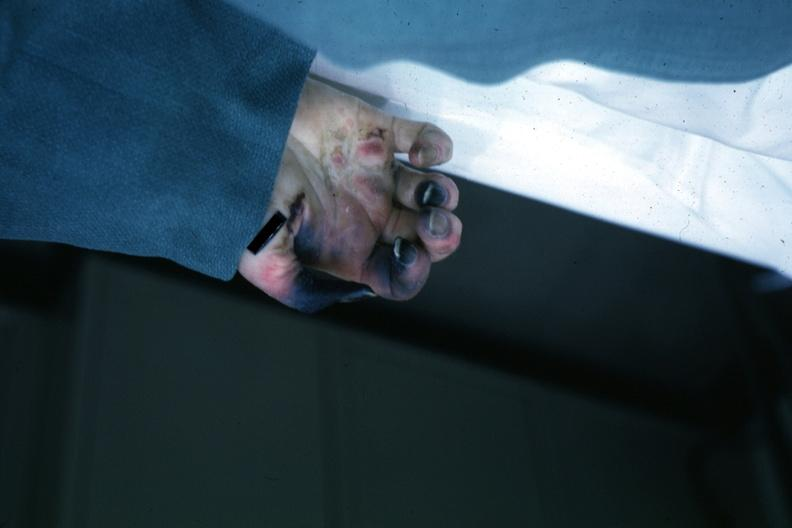what are present?
Answer the question using a single word or phrase. Extremities 